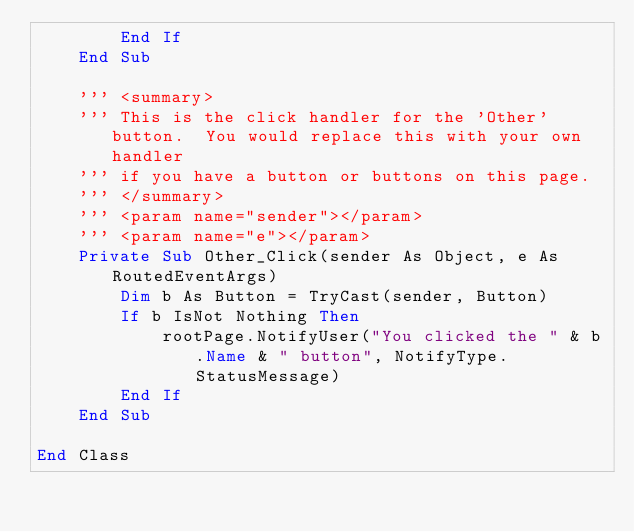<code> <loc_0><loc_0><loc_500><loc_500><_VisualBasic_>        End If
    End Sub

    ''' <summary>
    ''' This is the click handler for the 'Other' button.  You would replace this with your own handler
    ''' if you have a button or buttons on this page.
    ''' </summary>
    ''' <param name="sender"></param>
    ''' <param name="e"></param>
    Private Sub Other_Click(sender As Object, e As RoutedEventArgs)
        Dim b As Button = TryCast(sender, Button)
        If b IsNot Nothing Then
            rootPage.NotifyUser("You clicked the " & b.Name & " button", NotifyType.StatusMessage)
        End If
    End Sub

End Class
</code> 